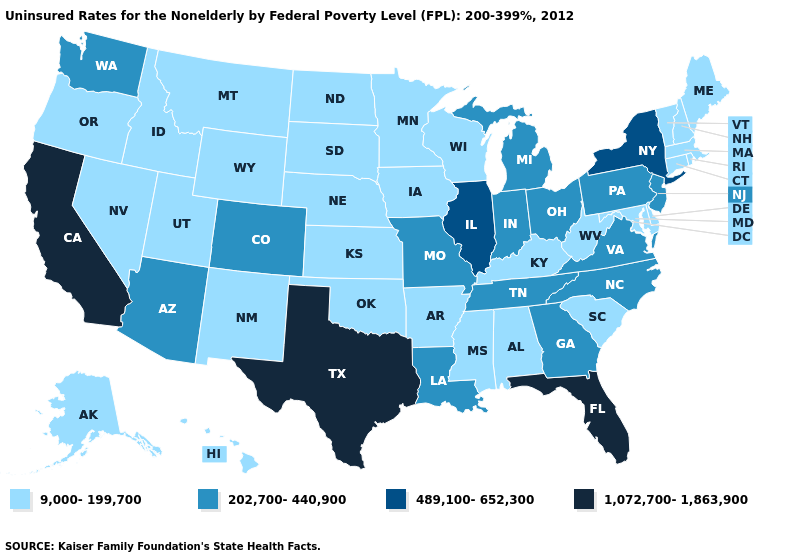Name the states that have a value in the range 1,072,700-1,863,900?
Concise answer only. California, Florida, Texas. Which states hav the highest value in the Northeast?
Quick response, please. New York. Does the first symbol in the legend represent the smallest category?
Write a very short answer. Yes. Does Ohio have the lowest value in the USA?
Answer briefly. No. What is the highest value in states that border New York?
Concise answer only. 202,700-440,900. Does Arizona have a lower value than Colorado?
Short answer required. No. Does Kentucky have the same value as Maryland?
Write a very short answer. Yes. Does the map have missing data?
Give a very brief answer. No. Does Colorado have the highest value in the USA?
Quick response, please. No. Which states have the highest value in the USA?
Write a very short answer. California, Florida, Texas. Among the states that border Tennessee , does Missouri have the highest value?
Be succinct. Yes. Name the states that have a value in the range 9,000-199,700?
Keep it brief. Alabama, Alaska, Arkansas, Connecticut, Delaware, Hawaii, Idaho, Iowa, Kansas, Kentucky, Maine, Maryland, Massachusetts, Minnesota, Mississippi, Montana, Nebraska, Nevada, New Hampshire, New Mexico, North Dakota, Oklahoma, Oregon, Rhode Island, South Carolina, South Dakota, Utah, Vermont, West Virginia, Wisconsin, Wyoming. Name the states that have a value in the range 9,000-199,700?
Answer briefly. Alabama, Alaska, Arkansas, Connecticut, Delaware, Hawaii, Idaho, Iowa, Kansas, Kentucky, Maine, Maryland, Massachusetts, Minnesota, Mississippi, Montana, Nebraska, Nevada, New Hampshire, New Mexico, North Dakota, Oklahoma, Oregon, Rhode Island, South Carolina, South Dakota, Utah, Vermont, West Virginia, Wisconsin, Wyoming. Among the states that border Delaware , which have the highest value?
Short answer required. New Jersey, Pennsylvania. Is the legend a continuous bar?
Quick response, please. No. 